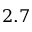<formula> <loc_0><loc_0><loc_500><loc_500>2 . 7</formula> 